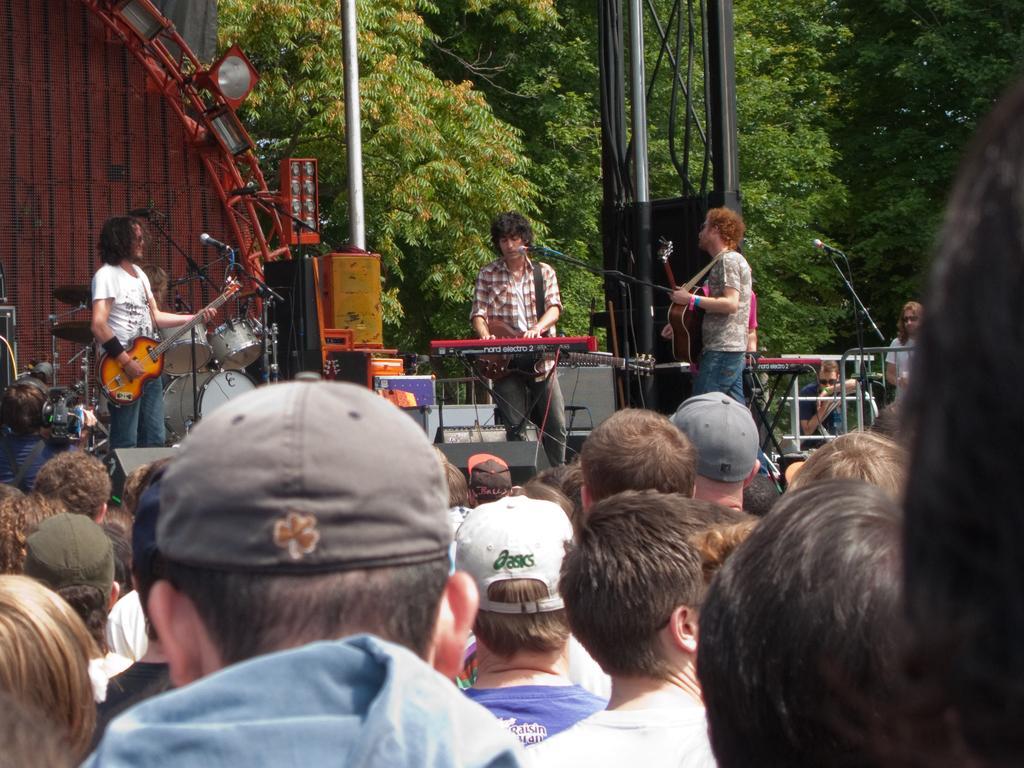Can you describe this image briefly? In this picture I can see a group of people among them some are standing on the stage and playing musical instruments. Here I can see microphones and some other objects on the stage. In the background I can see pole and trees. Here I can see stage lights. 